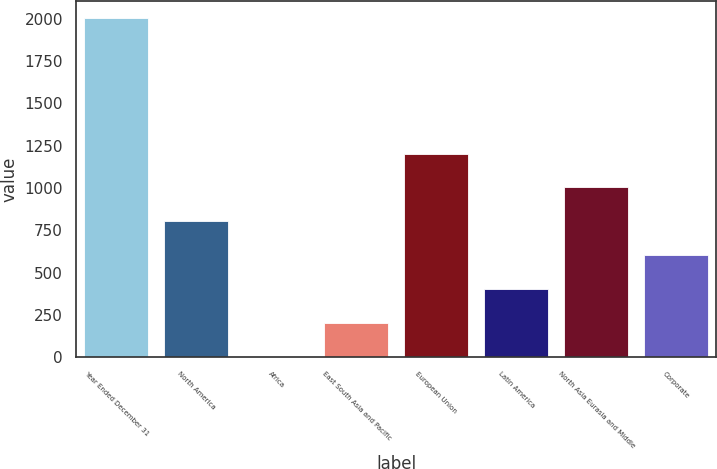Convert chart to OTSL. <chart><loc_0><loc_0><loc_500><loc_500><bar_chart><fcel>Year Ended December 31<fcel>North America<fcel>Africa<fcel>East South Asia and Pacific<fcel>European Union<fcel>Latin America<fcel>North Asia Eurasia and Middle<fcel>Corporate<nl><fcel>2003<fcel>804.08<fcel>4.8<fcel>204.62<fcel>1203.72<fcel>404.44<fcel>1003.9<fcel>604.26<nl></chart> 